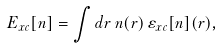Convert formula to latex. <formula><loc_0><loc_0><loc_500><loc_500>E _ { x c } [ n ] = \int d { r } \, n ( { r } ) \, \varepsilon _ { x c } [ n ] ( { r } ) ,</formula> 